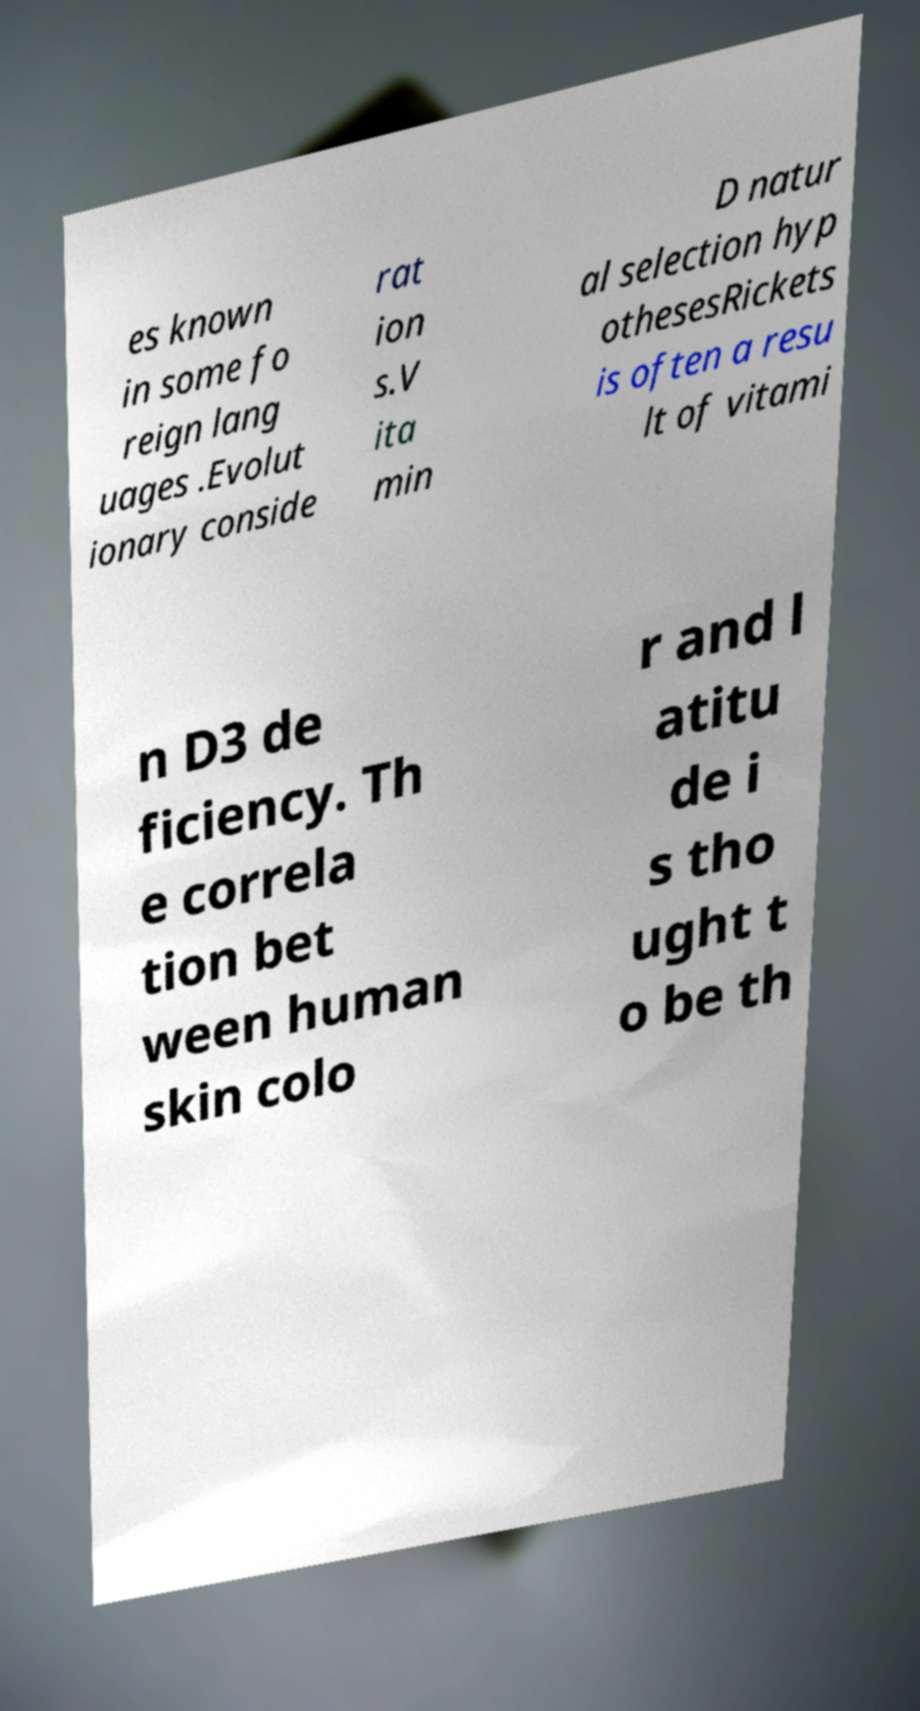Can you read and provide the text displayed in the image?This photo seems to have some interesting text. Can you extract and type it out for me? es known in some fo reign lang uages .Evolut ionary conside rat ion s.V ita min D natur al selection hyp othesesRickets is often a resu lt of vitami n D3 de ficiency. Th e correla tion bet ween human skin colo r and l atitu de i s tho ught t o be th 